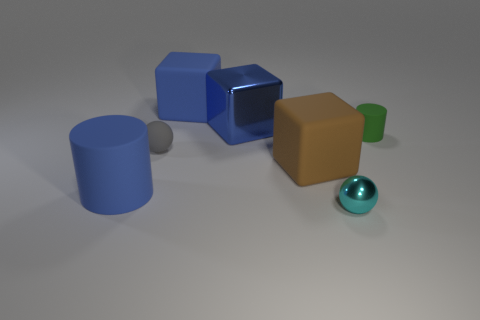Subtract all big blue matte cubes. How many cubes are left? 2 Add 1 large blue metallic things. How many objects exist? 8 Subtract all green spheres. How many blue blocks are left? 2 Subtract 1 cubes. How many cubes are left? 2 Subtract all cubes. How many objects are left? 4 Subtract all purple blocks. Subtract all cyan balls. How many blocks are left? 3 Subtract all cyan things. Subtract all big blue metal things. How many objects are left? 5 Add 7 tiny objects. How many tiny objects are left? 10 Add 7 green things. How many green things exist? 8 Subtract 1 blue blocks. How many objects are left? 6 